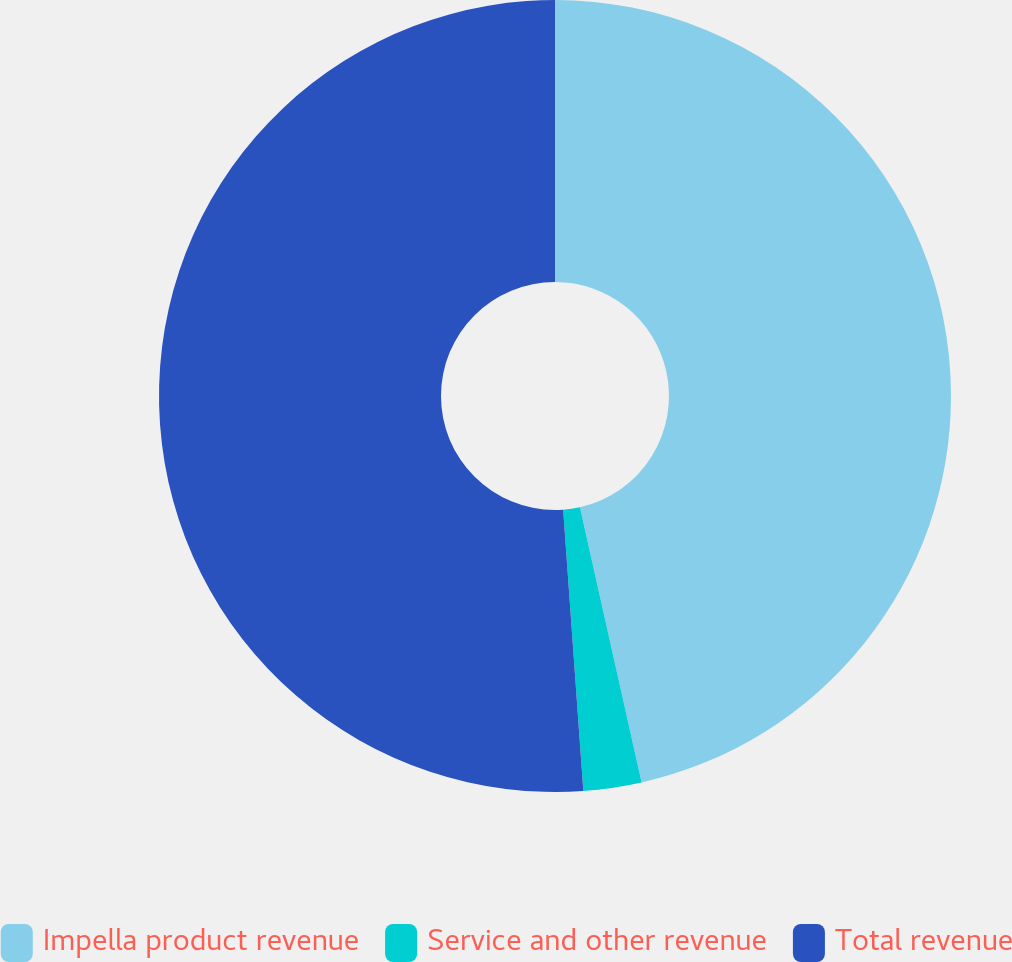Convert chart. <chart><loc_0><loc_0><loc_500><loc_500><pie_chart><fcel>Impella product revenue<fcel>Service and other revenue<fcel>Total revenue<nl><fcel>46.49%<fcel>2.37%<fcel>51.14%<nl></chart> 